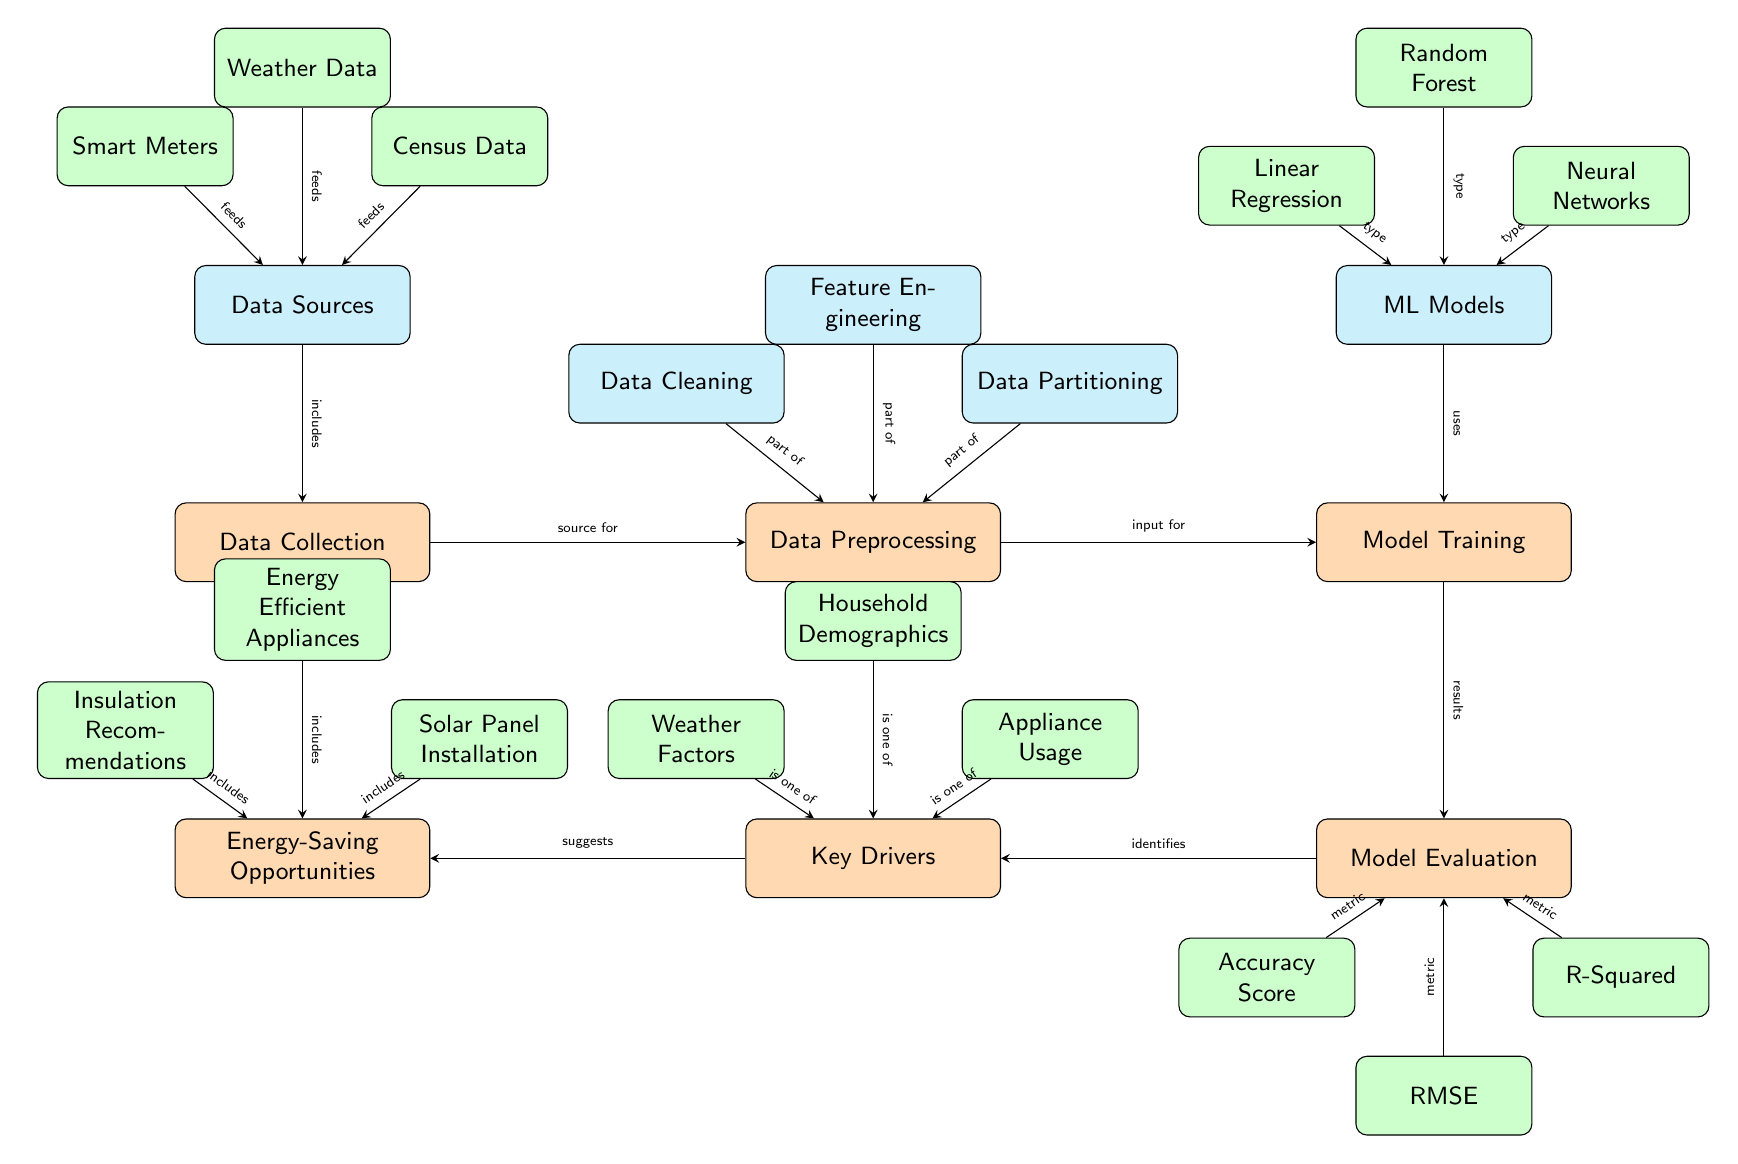What are the three main nodes in this diagram? The diagram prominently displays three main nodes: Data Collection, Data Preprocessing, and Model Training. These nodes represent the primary stages in the machine learning analysis of energy consumption patterns.
Answer: Data Collection, Data Preprocessing, Model Training How many sub-nodes are connected to the Data Preprocessing node? The Data Preprocessing node is connected to three sub-nodes: Data Cleaning, Feature Engineering, and Data Partitioning, indicating key processes in preparing the data for model training.
Answer: 3 What type of machine learning models are included in the Model Training node? The Model Training node includes three types of machine learning models: Linear Regression, Random Forest, and Neural Networks, representing various approaches to analyze energy consumption patterns.
Answer: Linear Regression, Random Forest, Neural Networks Which metric is used to identify key drivers of energy consumption? The model evaluation process identifies key drivers such as weather factors, household demographics, and appliance usage, which contribute to the understanding of energy consumption patterns in residential areas.
Answer: Key Drivers What is one of the energy-saving opportunities suggested in the diagram? The diagram suggests several energy-saving opportunities, including Insulation Recommendations. This highlights methods that homeowners can consider to reduce energy consumption effectively.
Answer: Insulation Recommendations Which edge connects the accuracy score metric and the model evaluation node? The edge from the model evaluation node to the accuracy score metric indicates that the accuracy score is one of the metrics used to evaluate the performance of the trained models.
Answer: Accuracy Score What data sources are used in the data collection process? The data collection process uses various data sources, which include Smart Meters, Weather Data, and Census Data, essential for analyzing energy consumption patterns accurately.
Answer: Smart Meters, Weather Data, Census Data How does the Data Preprocessing node relate to the Model Training node? The Data Preprocessing node serves as an input for the Model Training node, indicating that data must be processed before it can be used to train machine learning models.
Answer: Input for Model Training What drives the model evaluation process? The model evaluation process is driven by the results generated from the Model Training node, which include metrics like accuracy score, RMSE, and R-squared that help in assessing model performance.
Answer: Model Training 